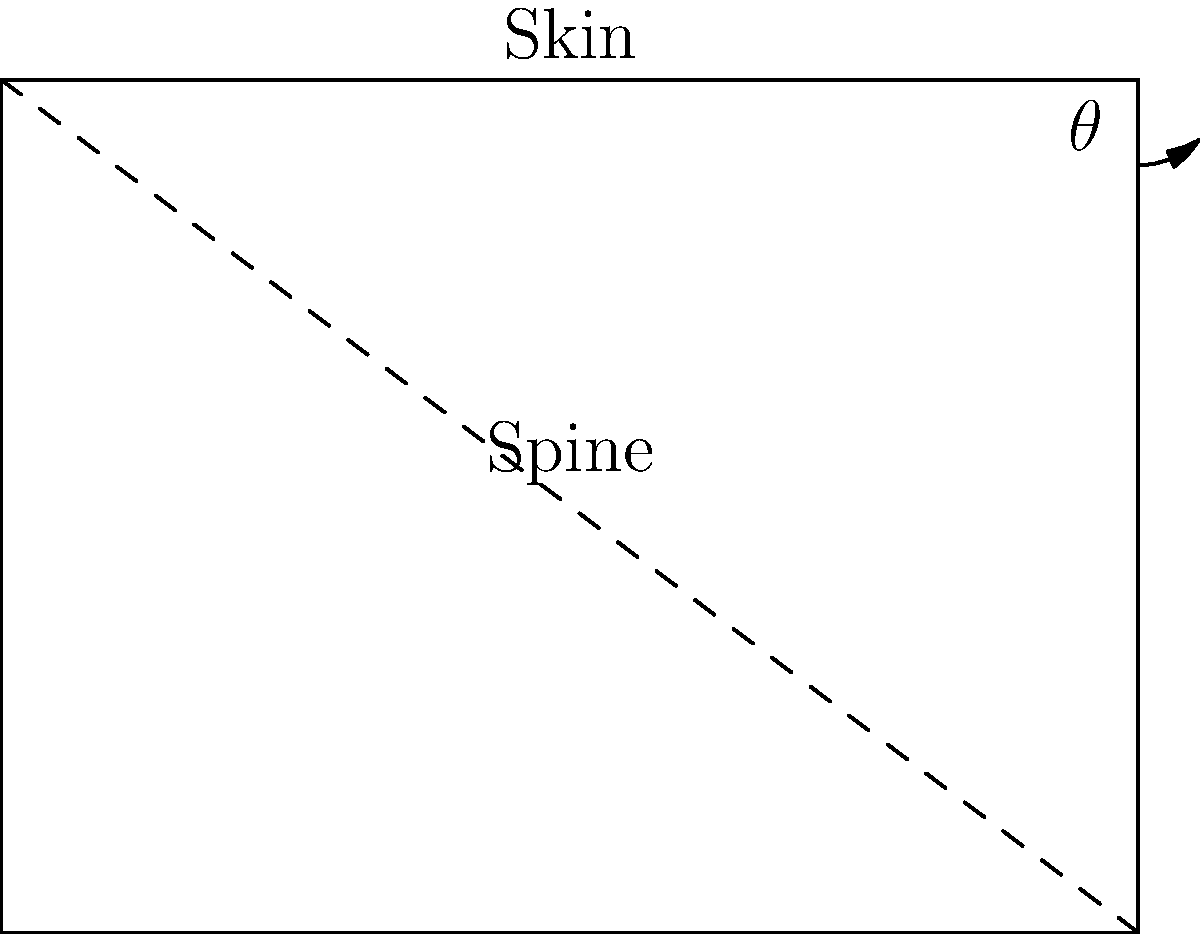In epidural anesthesia, the angle of needle insertion is crucial for successful placement. Given the diagram of a simplified spine cross-section, where the distance from the skin to the epidural space is 4 cm, and the horizontal distance from the entry point to the target is 3 cm, what is the optimal angle $\theta$ for needle insertion? To determine the optimal angle $\theta$ for needle insertion, we can use trigonometry:

1. The diagram forms a right-angled triangle.
2. We know the opposite side (horizontal distance) = 3 cm
3. We know the adjacent side (depth to epidural space) = 4 cm
4. We can use the tangent function to find the angle:

   $\tan(\theta) = \frac{\text{opposite}}{\text{adjacent}} = \frac{3}{4}$

5. To find $\theta$, we take the inverse tangent (arctan or $\tan^{-1}$):

   $\theta = \tan^{-1}(\frac{3}{4})$

6. Calculating this:
   
   $\theta \approx 36.87°$

7. In clinical practice, we usually round to the nearest degree:

   $\theta \approx 37°$

This angle provides the optimal path for the needle to reach the epidural space while minimizing the risk of overshooting or undershooting the target.
Answer: 37° 